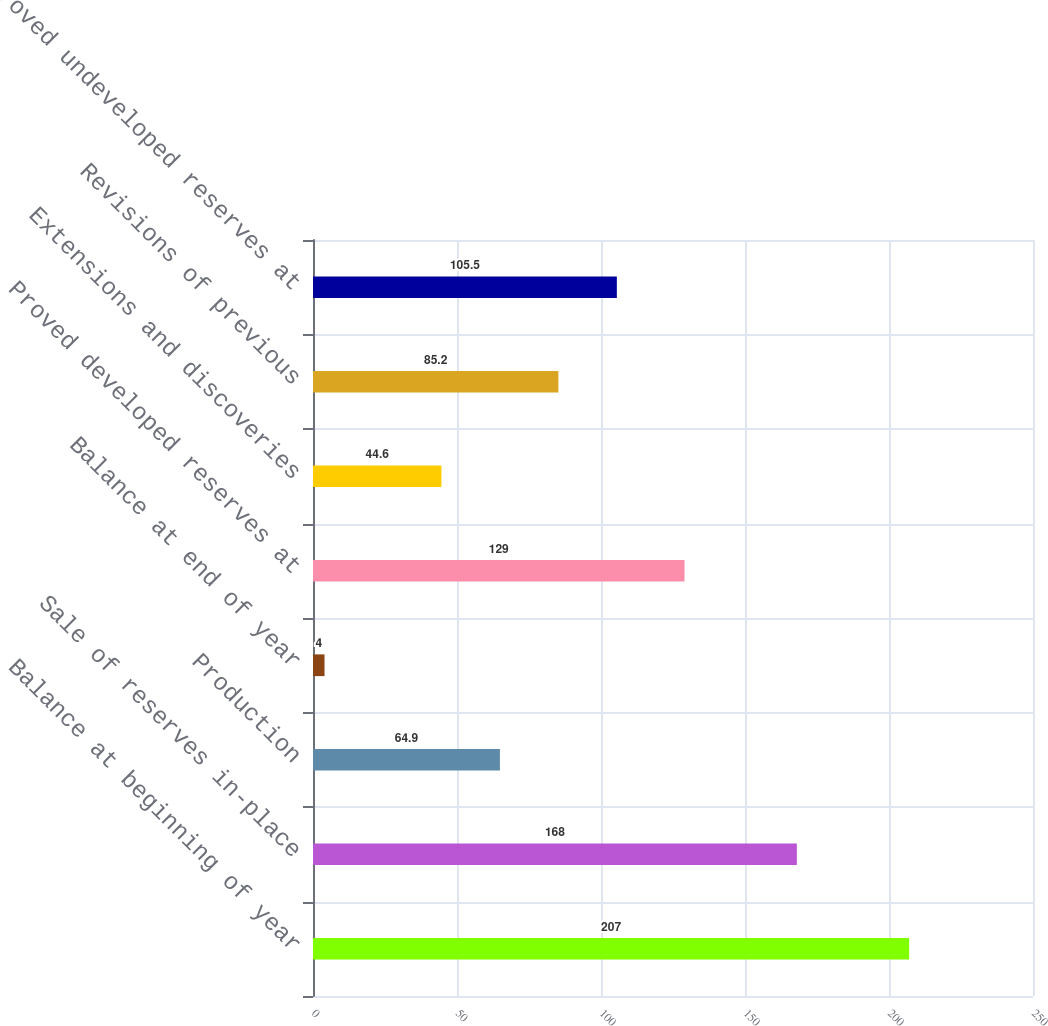Convert chart. <chart><loc_0><loc_0><loc_500><loc_500><bar_chart><fcel>Balance at beginning of year<fcel>Sale of reserves in-place<fcel>Production<fcel>Balance at end of year<fcel>Proved developed reserves at<fcel>Extensions and discoveries<fcel>Revisions of previous<fcel>Proved undeveloped reserves at<nl><fcel>207<fcel>168<fcel>64.9<fcel>4<fcel>129<fcel>44.6<fcel>85.2<fcel>105.5<nl></chart> 